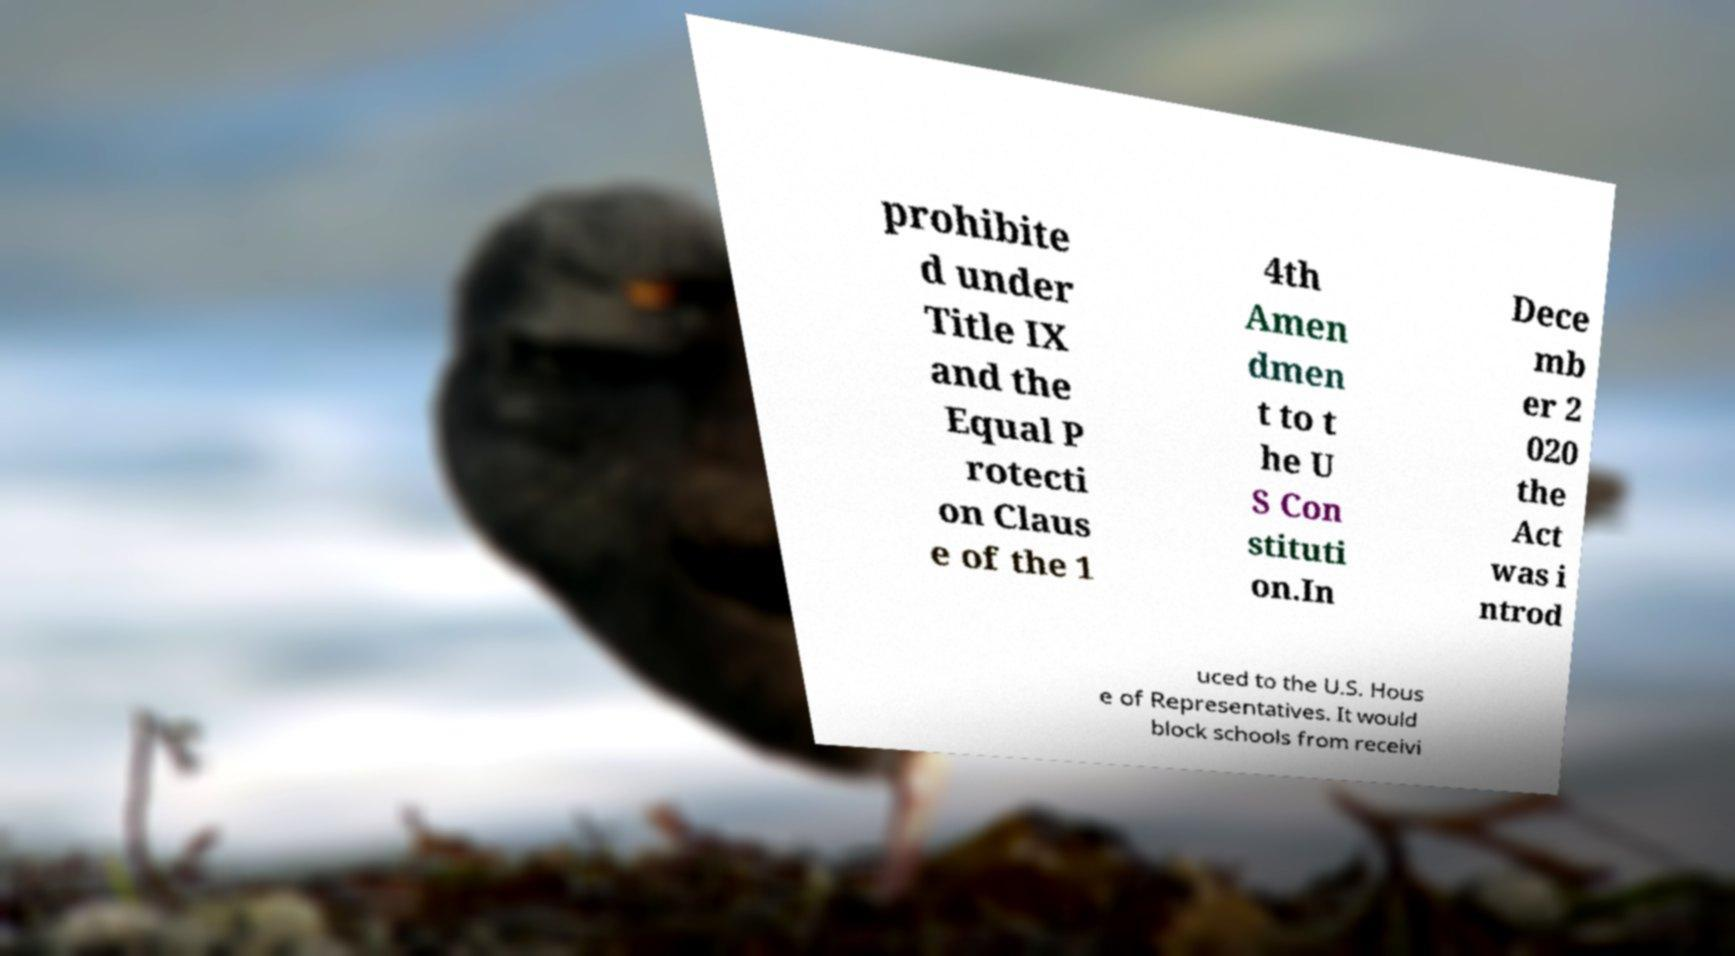Please identify and transcribe the text found in this image. prohibite d under Title IX and the Equal P rotecti on Claus e of the 1 4th Amen dmen t to t he U S Con stituti on.In Dece mb er 2 020 the Act was i ntrod uced to the U.S. Hous e of Representatives. It would block schools from receivi 